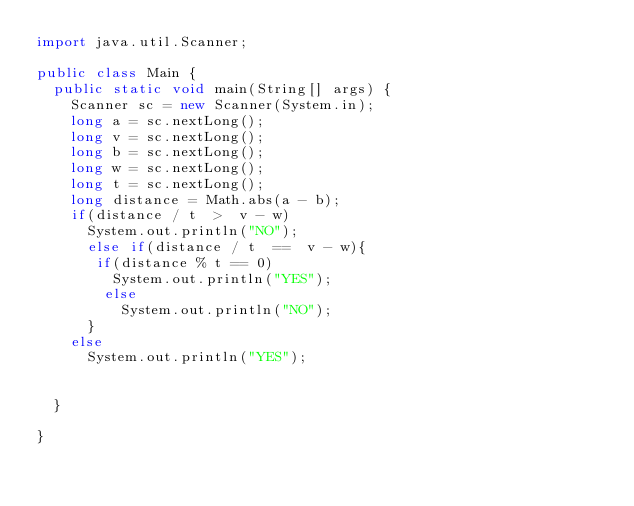Convert code to text. <code><loc_0><loc_0><loc_500><loc_500><_Java_>import java.util.Scanner;

public class Main {
	public static void main(String[] args) {
		Scanner sc = new Scanner(System.in);
		long a = sc.nextLong();
		long v = sc.nextLong();
		long b = sc.nextLong();
		long w = sc.nextLong();
		long t = sc.nextLong();
		long distance = Math.abs(a - b);
		if(distance / t  >  v - w)
			System.out.println("NO");
      else if(distance / t  ==  v - w){
       if(distance % t == 0)
         System.out.println("YES");
        else
          System.out.println("NO");
      }
		else
			System.out.println("YES");


	}

}
</code> 